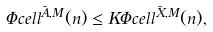<formula> <loc_0><loc_0><loc_500><loc_500>\Phi c e l l ^ { \tilde { A } , M } ( n ) \leq K \Phi c e l l ^ { \tilde { X } , M } ( n ) ,</formula> 